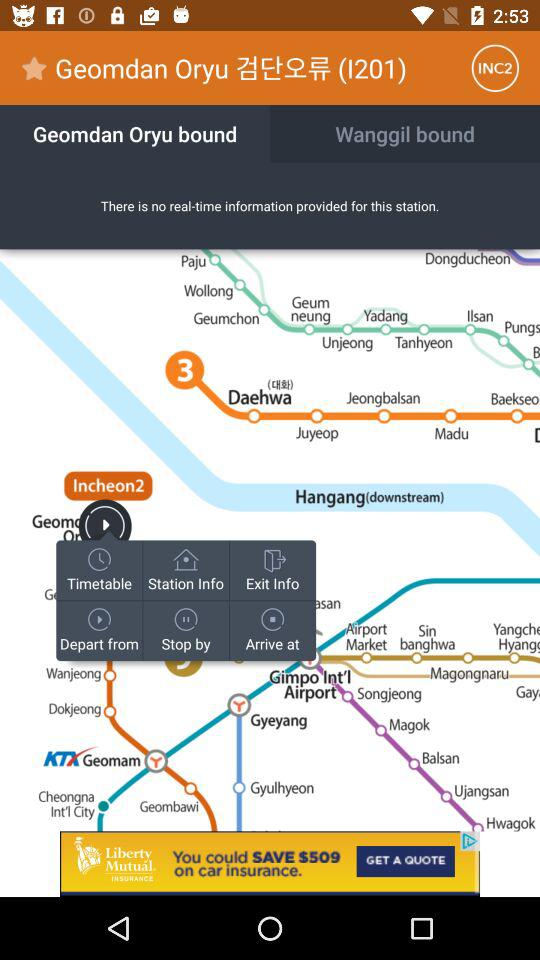What is the last version? The last version is 5.5.1. 